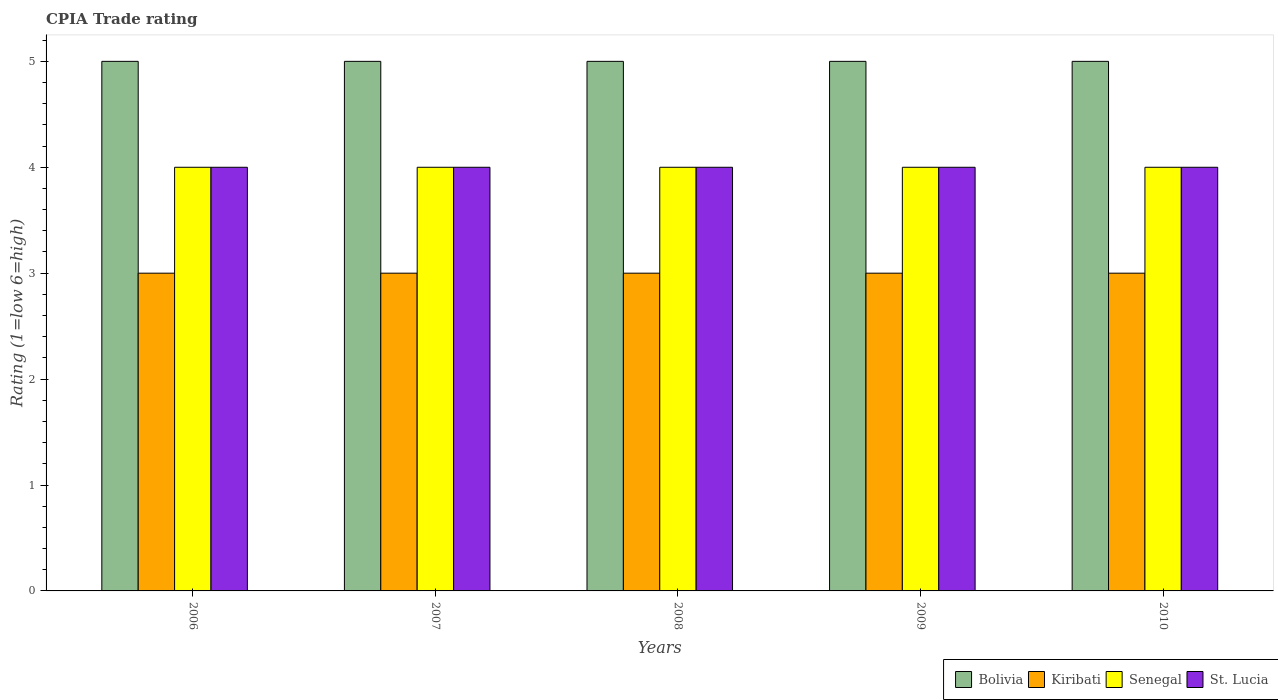How many groups of bars are there?
Ensure brevity in your answer.  5. Are the number of bars per tick equal to the number of legend labels?
Offer a terse response. Yes. What is the label of the 5th group of bars from the left?
Offer a terse response. 2010. What is the CPIA rating in St. Lucia in 2008?
Provide a succinct answer. 4. Across all years, what is the maximum CPIA rating in Bolivia?
Your response must be concise. 5. In which year was the CPIA rating in St. Lucia minimum?
Offer a very short reply. 2006. What is the difference between the CPIA rating in Bolivia in 2008 and that in 2009?
Offer a very short reply. 0. What is the difference between the CPIA rating in Bolivia in 2008 and the CPIA rating in Kiribati in 2009?
Ensure brevity in your answer.  2. What is the average CPIA rating in Bolivia per year?
Your answer should be very brief. 5. In the year 2008, what is the difference between the CPIA rating in St. Lucia and CPIA rating in Kiribati?
Make the answer very short. 1. In how many years, is the CPIA rating in St. Lucia greater than 4.6?
Keep it short and to the point. 0. Is the difference between the CPIA rating in St. Lucia in 2006 and 2010 greater than the difference between the CPIA rating in Kiribati in 2006 and 2010?
Keep it short and to the point. No. What is the difference between the highest and the lowest CPIA rating in Bolivia?
Give a very brief answer. 0. Is the sum of the CPIA rating in Bolivia in 2009 and 2010 greater than the maximum CPIA rating in Senegal across all years?
Your response must be concise. Yes. Is it the case that in every year, the sum of the CPIA rating in Senegal and CPIA rating in St. Lucia is greater than the sum of CPIA rating in Kiribati and CPIA rating in Bolivia?
Your answer should be very brief. Yes. What does the 2nd bar from the left in 2007 represents?
Your answer should be compact. Kiribati. How many bars are there?
Your response must be concise. 20. What is the difference between two consecutive major ticks on the Y-axis?
Provide a short and direct response. 1. What is the title of the graph?
Give a very brief answer. CPIA Trade rating. Does "Costa Rica" appear as one of the legend labels in the graph?
Provide a succinct answer. No. What is the Rating (1=low 6=high) of Bolivia in 2006?
Your answer should be compact. 5. What is the Rating (1=low 6=high) of Senegal in 2006?
Your answer should be very brief. 4. What is the Rating (1=low 6=high) of Bolivia in 2007?
Keep it short and to the point. 5. What is the Rating (1=low 6=high) in Kiribati in 2007?
Ensure brevity in your answer.  3. What is the Rating (1=low 6=high) of Senegal in 2007?
Give a very brief answer. 4. What is the Rating (1=low 6=high) of Bolivia in 2008?
Make the answer very short. 5. What is the Rating (1=low 6=high) in Senegal in 2009?
Offer a very short reply. 4. What is the Rating (1=low 6=high) of Bolivia in 2010?
Make the answer very short. 5. What is the Rating (1=low 6=high) of Kiribati in 2010?
Your response must be concise. 3. What is the Rating (1=low 6=high) in Senegal in 2010?
Offer a very short reply. 4. What is the Rating (1=low 6=high) of St. Lucia in 2010?
Your response must be concise. 4. Across all years, what is the maximum Rating (1=low 6=high) of Kiribati?
Keep it short and to the point. 3. Across all years, what is the maximum Rating (1=low 6=high) of Senegal?
Offer a terse response. 4. Across all years, what is the minimum Rating (1=low 6=high) in Kiribati?
Make the answer very short. 3. Across all years, what is the minimum Rating (1=low 6=high) in Senegal?
Make the answer very short. 4. Across all years, what is the minimum Rating (1=low 6=high) in St. Lucia?
Your answer should be compact. 4. What is the total Rating (1=low 6=high) in Bolivia in the graph?
Ensure brevity in your answer.  25. What is the total Rating (1=low 6=high) of Kiribati in the graph?
Give a very brief answer. 15. What is the total Rating (1=low 6=high) of St. Lucia in the graph?
Your response must be concise. 20. What is the difference between the Rating (1=low 6=high) of Kiribati in 2006 and that in 2007?
Your answer should be very brief. 0. What is the difference between the Rating (1=low 6=high) of Senegal in 2006 and that in 2007?
Your answer should be compact. 0. What is the difference between the Rating (1=low 6=high) of Bolivia in 2006 and that in 2008?
Keep it short and to the point. 0. What is the difference between the Rating (1=low 6=high) in Senegal in 2006 and that in 2008?
Offer a very short reply. 0. What is the difference between the Rating (1=low 6=high) of Kiribati in 2006 and that in 2009?
Provide a succinct answer. 0. What is the difference between the Rating (1=low 6=high) of Senegal in 2006 and that in 2009?
Give a very brief answer. 0. What is the difference between the Rating (1=low 6=high) of Kiribati in 2007 and that in 2008?
Offer a very short reply. 0. What is the difference between the Rating (1=low 6=high) in Senegal in 2007 and that in 2008?
Provide a succinct answer. 0. What is the difference between the Rating (1=low 6=high) of St. Lucia in 2007 and that in 2009?
Provide a succinct answer. 0. What is the difference between the Rating (1=low 6=high) of Kiribati in 2007 and that in 2010?
Your answer should be very brief. 0. What is the difference between the Rating (1=low 6=high) in Bolivia in 2008 and that in 2009?
Keep it short and to the point. 0. What is the difference between the Rating (1=low 6=high) in Kiribati in 2008 and that in 2009?
Your answer should be very brief. 0. What is the difference between the Rating (1=low 6=high) in Senegal in 2008 and that in 2009?
Offer a terse response. 0. What is the difference between the Rating (1=low 6=high) of St. Lucia in 2008 and that in 2009?
Offer a very short reply. 0. What is the difference between the Rating (1=low 6=high) in Bolivia in 2008 and that in 2010?
Offer a very short reply. 0. What is the difference between the Rating (1=low 6=high) in Senegal in 2008 and that in 2010?
Provide a short and direct response. 0. What is the difference between the Rating (1=low 6=high) in St. Lucia in 2008 and that in 2010?
Your response must be concise. 0. What is the difference between the Rating (1=low 6=high) of St. Lucia in 2009 and that in 2010?
Your response must be concise. 0. What is the difference between the Rating (1=low 6=high) in Senegal in 2006 and the Rating (1=low 6=high) in St. Lucia in 2007?
Your answer should be very brief. 0. What is the difference between the Rating (1=low 6=high) of Bolivia in 2006 and the Rating (1=low 6=high) of Kiribati in 2008?
Your answer should be compact. 2. What is the difference between the Rating (1=low 6=high) of Bolivia in 2006 and the Rating (1=low 6=high) of St. Lucia in 2008?
Give a very brief answer. 1. What is the difference between the Rating (1=low 6=high) in Kiribati in 2006 and the Rating (1=low 6=high) in Senegal in 2008?
Your response must be concise. -1. What is the difference between the Rating (1=low 6=high) of Bolivia in 2006 and the Rating (1=low 6=high) of Kiribati in 2009?
Make the answer very short. 2. What is the difference between the Rating (1=low 6=high) of Bolivia in 2006 and the Rating (1=low 6=high) of Senegal in 2009?
Your answer should be compact. 1. What is the difference between the Rating (1=low 6=high) in Bolivia in 2006 and the Rating (1=low 6=high) in St. Lucia in 2009?
Make the answer very short. 1. What is the difference between the Rating (1=low 6=high) of Kiribati in 2006 and the Rating (1=low 6=high) of St. Lucia in 2009?
Offer a very short reply. -1. What is the difference between the Rating (1=low 6=high) of Bolivia in 2006 and the Rating (1=low 6=high) of St. Lucia in 2010?
Offer a terse response. 1. What is the difference between the Rating (1=low 6=high) of Senegal in 2006 and the Rating (1=low 6=high) of St. Lucia in 2010?
Provide a succinct answer. 0. What is the difference between the Rating (1=low 6=high) of Bolivia in 2007 and the Rating (1=low 6=high) of Kiribati in 2008?
Your answer should be compact. 2. What is the difference between the Rating (1=low 6=high) in Bolivia in 2007 and the Rating (1=low 6=high) in Senegal in 2008?
Provide a short and direct response. 1. What is the difference between the Rating (1=low 6=high) of Kiribati in 2007 and the Rating (1=low 6=high) of Senegal in 2008?
Ensure brevity in your answer.  -1. What is the difference between the Rating (1=low 6=high) of Kiribati in 2007 and the Rating (1=low 6=high) of St. Lucia in 2008?
Offer a terse response. -1. What is the difference between the Rating (1=low 6=high) of Kiribati in 2007 and the Rating (1=low 6=high) of Senegal in 2009?
Offer a terse response. -1. What is the difference between the Rating (1=low 6=high) in Senegal in 2007 and the Rating (1=low 6=high) in St. Lucia in 2009?
Provide a succinct answer. 0. What is the difference between the Rating (1=low 6=high) in Bolivia in 2007 and the Rating (1=low 6=high) in Kiribati in 2010?
Your answer should be very brief. 2. What is the difference between the Rating (1=low 6=high) of Bolivia in 2008 and the Rating (1=low 6=high) of St. Lucia in 2009?
Offer a terse response. 1. What is the difference between the Rating (1=low 6=high) in Kiribati in 2008 and the Rating (1=low 6=high) in Senegal in 2009?
Your answer should be very brief. -1. What is the difference between the Rating (1=low 6=high) in Senegal in 2008 and the Rating (1=low 6=high) in St. Lucia in 2009?
Your response must be concise. 0. What is the difference between the Rating (1=low 6=high) in Bolivia in 2008 and the Rating (1=low 6=high) in St. Lucia in 2010?
Make the answer very short. 1. What is the difference between the Rating (1=low 6=high) in Bolivia in 2009 and the Rating (1=low 6=high) in Kiribati in 2010?
Offer a very short reply. 2. What is the difference between the Rating (1=low 6=high) in Bolivia in 2009 and the Rating (1=low 6=high) in St. Lucia in 2010?
Make the answer very short. 1. What is the difference between the Rating (1=low 6=high) in Kiribati in 2009 and the Rating (1=low 6=high) in Senegal in 2010?
Offer a very short reply. -1. What is the difference between the Rating (1=low 6=high) in Kiribati in 2009 and the Rating (1=low 6=high) in St. Lucia in 2010?
Offer a terse response. -1. What is the average Rating (1=low 6=high) in Bolivia per year?
Give a very brief answer. 5. In the year 2006, what is the difference between the Rating (1=low 6=high) in Bolivia and Rating (1=low 6=high) in Kiribati?
Keep it short and to the point. 2. In the year 2006, what is the difference between the Rating (1=low 6=high) in Bolivia and Rating (1=low 6=high) in St. Lucia?
Offer a terse response. 1. In the year 2006, what is the difference between the Rating (1=low 6=high) in Kiribati and Rating (1=low 6=high) in Senegal?
Your answer should be compact. -1. In the year 2007, what is the difference between the Rating (1=low 6=high) in Bolivia and Rating (1=low 6=high) in Kiribati?
Your answer should be very brief. 2. In the year 2007, what is the difference between the Rating (1=low 6=high) in Bolivia and Rating (1=low 6=high) in Senegal?
Your answer should be very brief. 1. In the year 2007, what is the difference between the Rating (1=low 6=high) of Kiribati and Rating (1=low 6=high) of Senegal?
Offer a very short reply. -1. In the year 2007, what is the difference between the Rating (1=low 6=high) in Senegal and Rating (1=low 6=high) in St. Lucia?
Offer a terse response. 0. In the year 2008, what is the difference between the Rating (1=low 6=high) in Bolivia and Rating (1=low 6=high) in Kiribati?
Your answer should be very brief. 2. In the year 2008, what is the difference between the Rating (1=low 6=high) of Kiribati and Rating (1=low 6=high) of St. Lucia?
Offer a terse response. -1. In the year 2009, what is the difference between the Rating (1=low 6=high) in Bolivia and Rating (1=low 6=high) in Kiribati?
Offer a very short reply. 2. In the year 2009, what is the difference between the Rating (1=low 6=high) of Bolivia and Rating (1=low 6=high) of Senegal?
Your response must be concise. 1. In the year 2009, what is the difference between the Rating (1=low 6=high) of Bolivia and Rating (1=low 6=high) of St. Lucia?
Your response must be concise. 1. In the year 2009, what is the difference between the Rating (1=low 6=high) of Kiribati and Rating (1=low 6=high) of Senegal?
Keep it short and to the point. -1. In the year 2010, what is the difference between the Rating (1=low 6=high) in Bolivia and Rating (1=low 6=high) in Kiribati?
Give a very brief answer. 2. In the year 2010, what is the difference between the Rating (1=low 6=high) in Bolivia and Rating (1=low 6=high) in Senegal?
Your answer should be very brief. 1. In the year 2010, what is the difference between the Rating (1=low 6=high) of Kiribati and Rating (1=low 6=high) of Senegal?
Provide a short and direct response. -1. In the year 2010, what is the difference between the Rating (1=low 6=high) in Kiribati and Rating (1=low 6=high) in St. Lucia?
Give a very brief answer. -1. What is the ratio of the Rating (1=low 6=high) in Bolivia in 2006 to that in 2007?
Provide a short and direct response. 1. What is the ratio of the Rating (1=low 6=high) of St. Lucia in 2006 to that in 2007?
Offer a terse response. 1. What is the ratio of the Rating (1=low 6=high) in Bolivia in 2006 to that in 2008?
Your answer should be very brief. 1. What is the ratio of the Rating (1=low 6=high) of St. Lucia in 2006 to that in 2008?
Offer a terse response. 1. What is the ratio of the Rating (1=low 6=high) in Bolivia in 2006 to that in 2009?
Your response must be concise. 1. What is the ratio of the Rating (1=low 6=high) of Kiribati in 2006 to that in 2010?
Provide a short and direct response. 1. What is the ratio of the Rating (1=low 6=high) of Senegal in 2006 to that in 2010?
Provide a succinct answer. 1. What is the ratio of the Rating (1=low 6=high) of Bolivia in 2007 to that in 2009?
Your answer should be compact. 1. What is the ratio of the Rating (1=low 6=high) of Senegal in 2007 to that in 2009?
Ensure brevity in your answer.  1. What is the ratio of the Rating (1=low 6=high) of Senegal in 2007 to that in 2010?
Ensure brevity in your answer.  1. What is the ratio of the Rating (1=low 6=high) in St. Lucia in 2007 to that in 2010?
Your response must be concise. 1. What is the ratio of the Rating (1=low 6=high) of Bolivia in 2008 to that in 2009?
Your answer should be compact. 1. What is the ratio of the Rating (1=low 6=high) of Kiribati in 2008 to that in 2009?
Your answer should be compact. 1. What is the ratio of the Rating (1=low 6=high) of St. Lucia in 2008 to that in 2009?
Provide a short and direct response. 1. What is the ratio of the Rating (1=low 6=high) of Kiribati in 2008 to that in 2010?
Offer a very short reply. 1. What is the ratio of the Rating (1=low 6=high) of St. Lucia in 2008 to that in 2010?
Provide a short and direct response. 1. What is the difference between the highest and the lowest Rating (1=low 6=high) in Bolivia?
Offer a terse response. 0. What is the difference between the highest and the lowest Rating (1=low 6=high) in Senegal?
Offer a very short reply. 0. What is the difference between the highest and the lowest Rating (1=low 6=high) in St. Lucia?
Offer a terse response. 0. 